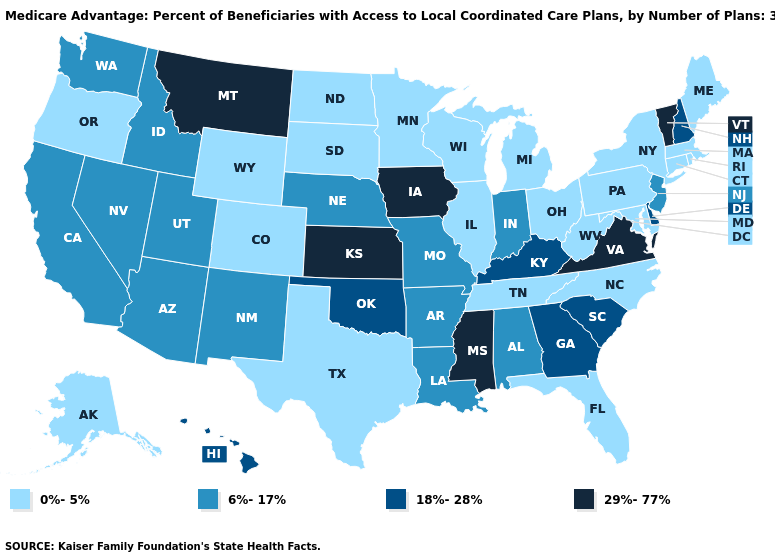Is the legend a continuous bar?
Concise answer only. No. Does Nevada have a lower value than New Hampshire?
Concise answer only. Yes. What is the highest value in states that border Illinois?
Concise answer only. 29%-77%. Name the states that have a value in the range 18%-28%?
Quick response, please. Delaware, Georgia, Hawaii, Kentucky, New Hampshire, Oklahoma, South Carolina. What is the value of Minnesota?
Write a very short answer. 0%-5%. What is the lowest value in the USA?
Be succinct. 0%-5%. Name the states that have a value in the range 6%-17%?
Concise answer only. California, Idaho, Indiana, Louisiana, Missouri, Nebraska, New Jersey, New Mexico, Nevada, Utah, Washington, Alabama, Arkansas, Arizona. What is the value of Nebraska?
Be succinct. 6%-17%. What is the value of Texas?
Write a very short answer. 0%-5%. What is the value of Arizona?
Give a very brief answer. 6%-17%. How many symbols are there in the legend?
Give a very brief answer. 4. Which states hav the highest value in the West?
Answer briefly. Montana. What is the highest value in states that border Maryland?
Keep it brief. 29%-77%. Name the states that have a value in the range 6%-17%?
Short answer required. California, Idaho, Indiana, Louisiana, Missouri, Nebraska, New Jersey, New Mexico, Nevada, Utah, Washington, Alabama, Arkansas, Arizona. What is the value of Minnesota?
Short answer required. 0%-5%. 